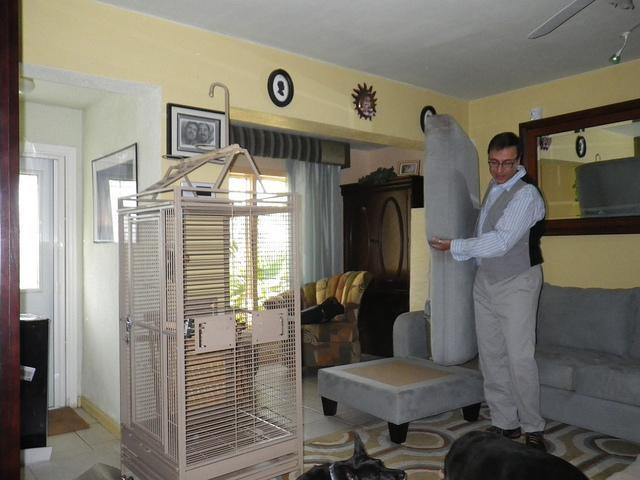How many couches are there?
Give a very brief answer. 2. How many dogs are there?
Give a very brief answer. 2. How many people have ties on?
Give a very brief answer. 0. 